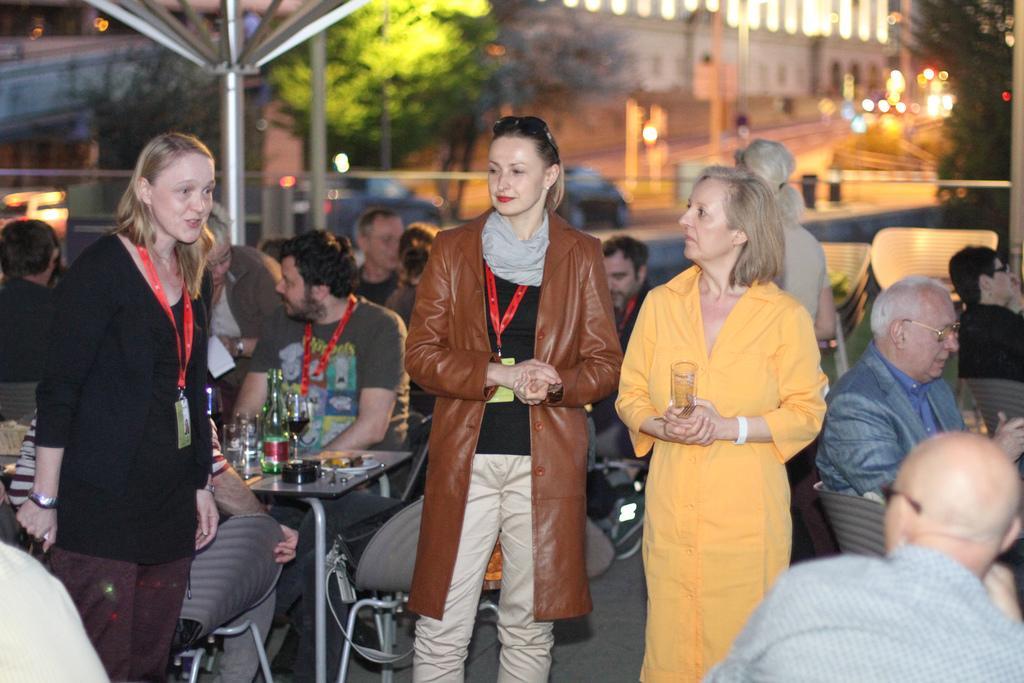How would you summarize this image in a sentence or two? In this picture there is a woman with black dress is standing and talking and there are three people standing and there are group of people sitting on the chairs and there are glasses and bottles on the table. At the back there is a building and there are trees and poles and there are vehicles on the road. 